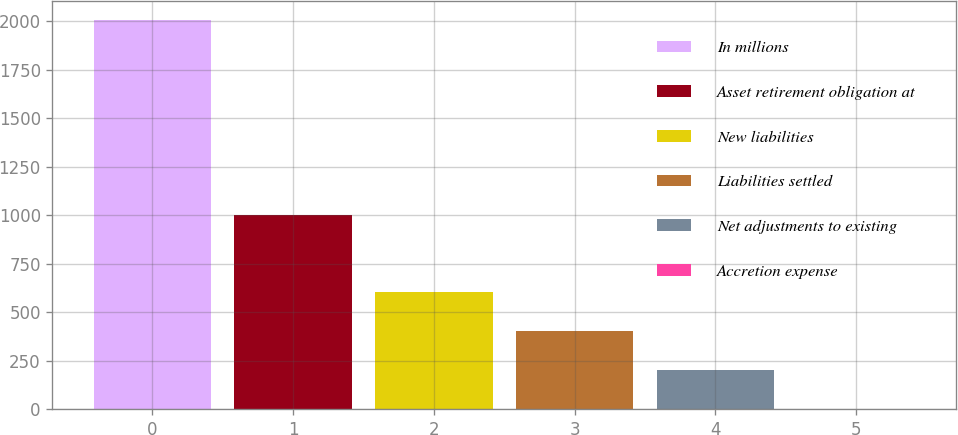Convert chart to OTSL. <chart><loc_0><loc_0><loc_500><loc_500><bar_chart><fcel>In millions<fcel>Asset retirement obligation at<fcel>New liabilities<fcel>Liabilities settled<fcel>Net adjustments to existing<fcel>Accretion expense<nl><fcel>2005<fcel>1003<fcel>602.2<fcel>401.8<fcel>201.4<fcel>1<nl></chart> 